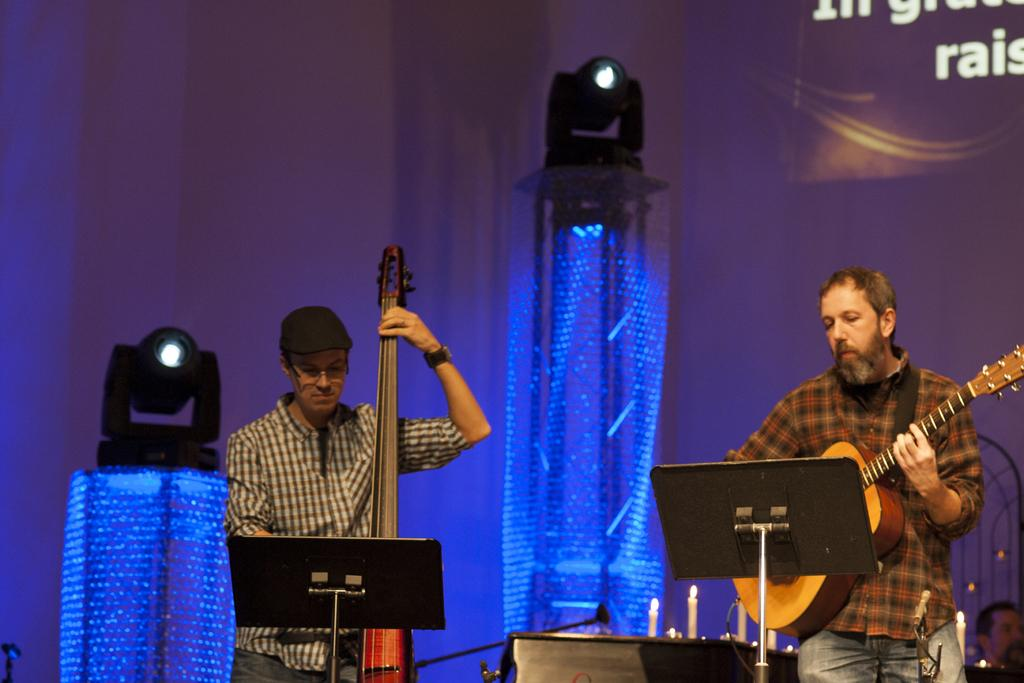How many people are in the image? There are two persons in the image. What are the two persons doing? The two persons are playing guitar. What object can be seen in the image besides the people? There is a table in the image. What is on the table? There are candles on the table. What can be seen in the image that provides light? There are lights visible in the image. What channel are the two persons watching on the table? There is no television or channel present in the image; the two persons are playing guitar. What color is the paint on the wall behind the table? There is no mention of paint or a wall in the image; it only features two persons playing guitar, a table, candles, and lights. 